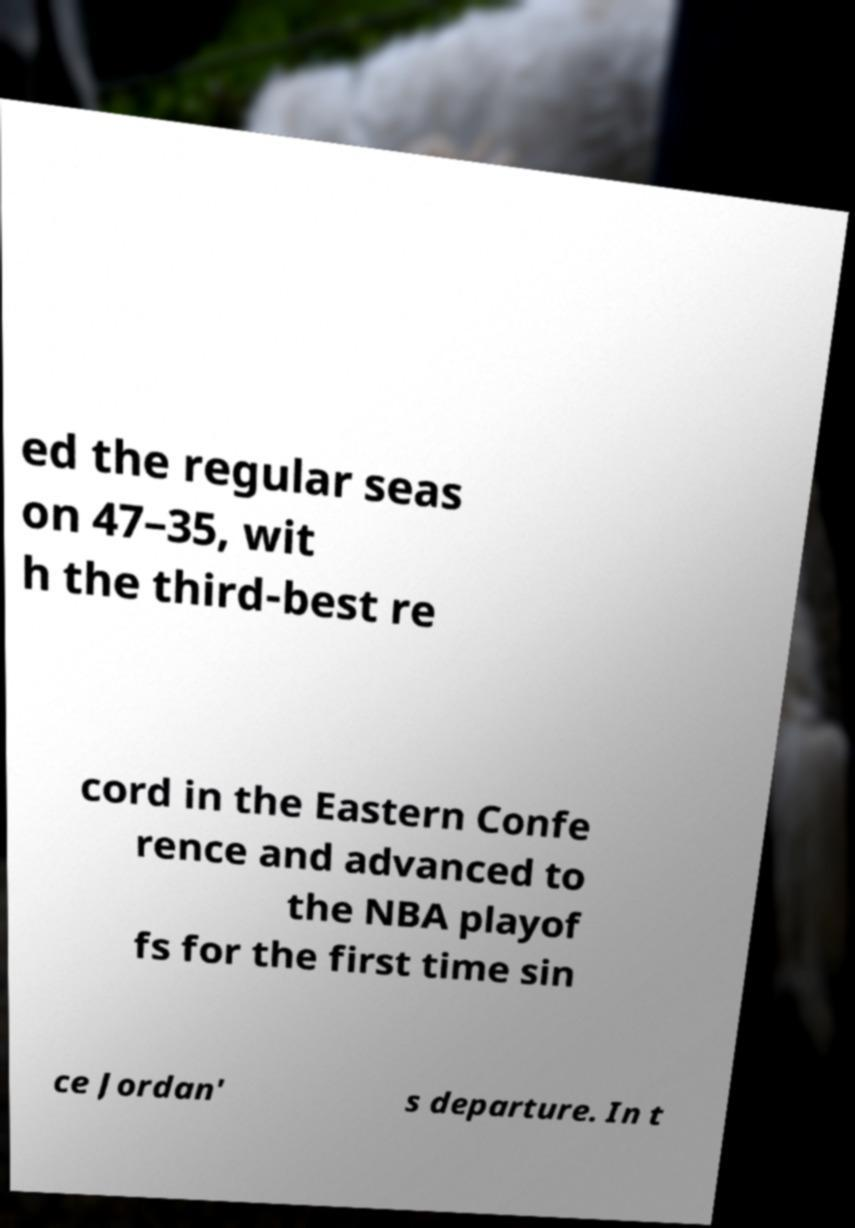Please identify and transcribe the text found in this image. ed the regular seas on 47–35, wit h the third-best re cord in the Eastern Confe rence and advanced to the NBA playof fs for the first time sin ce Jordan' s departure. In t 